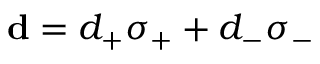Convert formula to latex. <formula><loc_0><loc_0><loc_500><loc_500>{ d } = d _ { + } \sigma _ { + } + d _ { - } \sigma _ { - }</formula> 